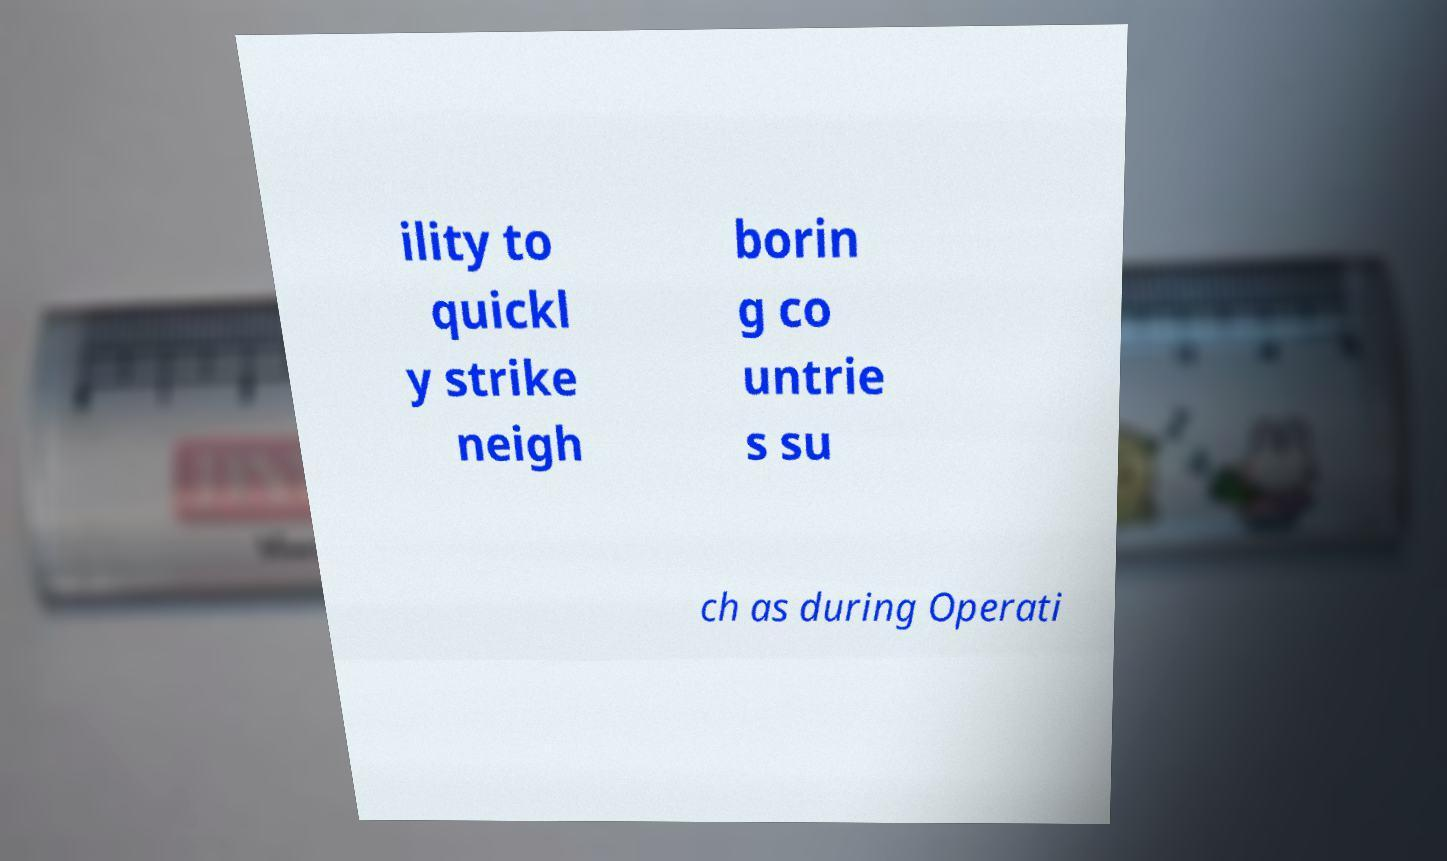Could you extract and type out the text from this image? ility to quickl y strike neigh borin g co untrie s su ch as during Operati 